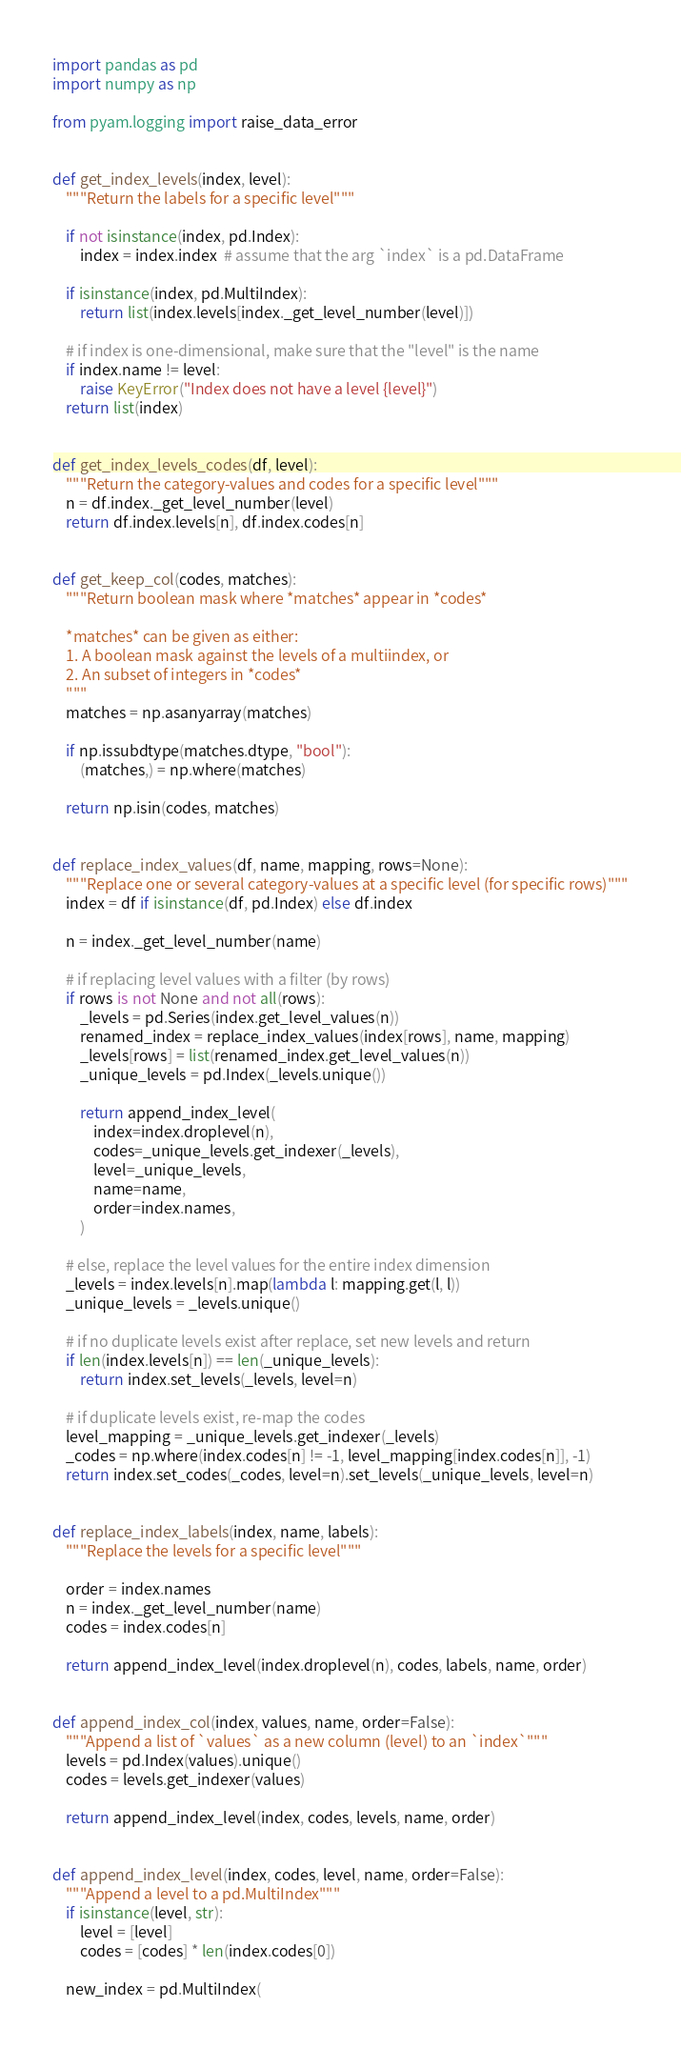Convert code to text. <code><loc_0><loc_0><loc_500><loc_500><_Python_>import pandas as pd
import numpy as np

from pyam.logging import raise_data_error


def get_index_levels(index, level):
    """Return the labels for a specific level"""

    if not isinstance(index, pd.Index):
        index = index.index  # assume that the arg `index` is a pd.DataFrame

    if isinstance(index, pd.MultiIndex):
        return list(index.levels[index._get_level_number(level)])

    # if index is one-dimensional, make sure that the "level" is the name
    if index.name != level:
        raise KeyError("Index does not have a level {level}")
    return list(index)


def get_index_levels_codes(df, level):
    """Return the category-values and codes for a specific level"""
    n = df.index._get_level_number(level)
    return df.index.levels[n], df.index.codes[n]


def get_keep_col(codes, matches):
    """Return boolean mask where *matches* appear in *codes*

    *matches* can be given as either:
    1. A boolean mask against the levels of a multiindex, or
    2. An subset of integers in *codes*
    """
    matches = np.asanyarray(matches)

    if np.issubdtype(matches.dtype, "bool"):
        (matches,) = np.where(matches)

    return np.isin(codes, matches)


def replace_index_values(df, name, mapping, rows=None):
    """Replace one or several category-values at a specific level (for specific rows)"""
    index = df if isinstance(df, pd.Index) else df.index

    n = index._get_level_number(name)

    # if replacing level values with a filter (by rows)
    if rows is not None and not all(rows):
        _levels = pd.Series(index.get_level_values(n))
        renamed_index = replace_index_values(index[rows], name, mapping)
        _levels[rows] = list(renamed_index.get_level_values(n))
        _unique_levels = pd.Index(_levels.unique())

        return append_index_level(
            index=index.droplevel(n),
            codes=_unique_levels.get_indexer(_levels),
            level=_unique_levels,
            name=name,
            order=index.names,
        )

    # else, replace the level values for the entire index dimension
    _levels = index.levels[n].map(lambda l: mapping.get(l, l))
    _unique_levels = _levels.unique()

    # if no duplicate levels exist after replace, set new levels and return
    if len(index.levels[n]) == len(_unique_levels):
        return index.set_levels(_levels, level=n)

    # if duplicate levels exist, re-map the codes
    level_mapping = _unique_levels.get_indexer(_levels)
    _codes = np.where(index.codes[n] != -1, level_mapping[index.codes[n]], -1)
    return index.set_codes(_codes, level=n).set_levels(_unique_levels, level=n)


def replace_index_labels(index, name, labels):
    """Replace the levels for a specific level"""

    order = index.names
    n = index._get_level_number(name)
    codes = index.codes[n]

    return append_index_level(index.droplevel(n), codes, labels, name, order)


def append_index_col(index, values, name, order=False):
    """Append a list of `values` as a new column (level) to an `index`"""
    levels = pd.Index(values).unique()
    codes = levels.get_indexer(values)

    return append_index_level(index, codes, levels, name, order)


def append_index_level(index, codes, level, name, order=False):
    """Append a level to a pd.MultiIndex"""
    if isinstance(level, str):
        level = [level]
        codes = [codes] * len(index.codes[0])

    new_index = pd.MultiIndex(</code> 